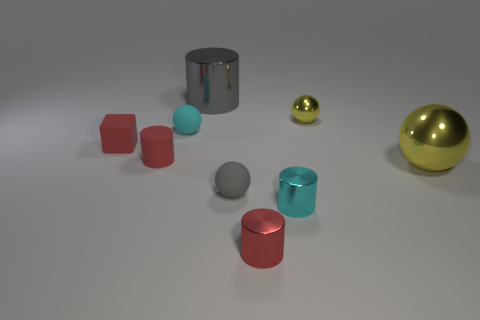There is a shiny cylinder behind the cyan metal cylinder; what is its size?
Provide a succinct answer. Large. There is another big object that is made of the same material as the large yellow object; what shape is it?
Provide a succinct answer. Cylinder. Is the small cyan cylinder made of the same material as the tiny red cylinder that is on the left side of the red metallic cylinder?
Ensure brevity in your answer.  No. There is a tiny cyan thing that is behind the big yellow metallic ball; is it the same shape as the gray shiny object?
Provide a succinct answer. No. There is a cyan thing that is the same shape as the large gray thing; what is its material?
Your response must be concise. Metal. There is a gray rubber thing; is it the same shape as the tiny shiny object behind the small cyan metal cylinder?
Provide a succinct answer. Yes. The tiny ball that is right of the tiny cyan rubber object and in front of the small yellow metal ball is what color?
Offer a very short reply. Gray. Is there a large green ball?
Provide a succinct answer. No. Are there the same number of small cyan objects that are behind the small red metallic object and cyan things?
Your answer should be compact. Yes. How many other things are there of the same shape as the tiny yellow shiny object?
Your answer should be very brief. 3. 